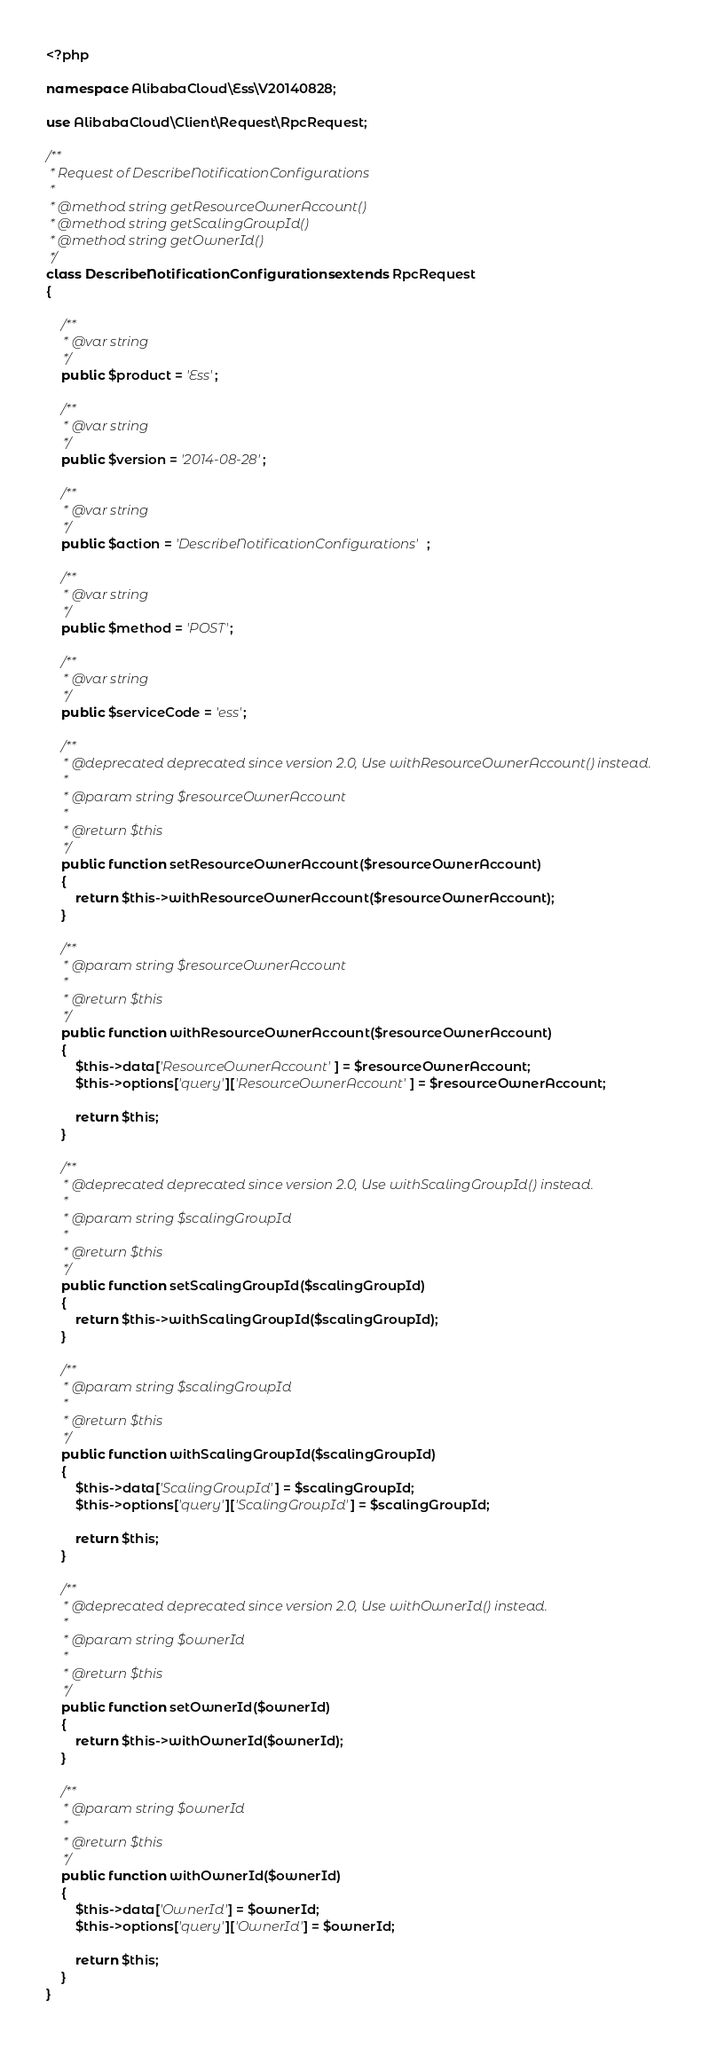<code> <loc_0><loc_0><loc_500><loc_500><_PHP_><?php

namespace AlibabaCloud\Ess\V20140828;

use AlibabaCloud\Client\Request\RpcRequest;

/**
 * Request of DescribeNotificationConfigurations
 *
 * @method string getResourceOwnerAccount()
 * @method string getScalingGroupId()
 * @method string getOwnerId()
 */
class DescribeNotificationConfigurations extends RpcRequest
{

    /**
     * @var string
     */
    public $product = 'Ess';

    /**
     * @var string
     */
    public $version = '2014-08-28';

    /**
     * @var string
     */
    public $action = 'DescribeNotificationConfigurations';

    /**
     * @var string
     */
    public $method = 'POST';

    /**
     * @var string
     */
    public $serviceCode = 'ess';

    /**
     * @deprecated deprecated since version 2.0, Use withResourceOwnerAccount() instead.
     *
     * @param string $resourceOwnerAccount
     *
     * @return $this
     */
    public function setResourceOwnerAccount($resourceOwnerAccount)
    {
        return $this->withResourceOwnerAccount($resourceOwnerAccount);
    }

    /**
     * @param string $resourceOwnerAccount
     *
     * @return $this
     */
    public function withResourceOwnerAccount($resourceOwnerAccount)
    {
        $this->data['ResourceOwnerAccount'] = $resourceOwnerAccount;
        $this->options['query']['ResourceOwnerAccount'] = $resourceOwnerAccount;

        return $this;
    }

    /**
     * @deprecated deprecated since version 2.0, Use withScalingGroupId() instead.
     *
     * @param string $scalingGroupId
     *
     * @return $this
     */
    public function setScalingGroupId($scalingGroupId)
    {
        return $this->withScalingGroupId($scalingGroupId);
    }

    /**
     * @param string $scalingGroupId
     *
     * @return $this
     */
    public function withScalingGroupId($scalingGroupId)
    {
        $this->data['ScalingGroupId'] = $scalingGroupId;
        $this->options['query']['ScalingGroupId'] = $scalingGroupId;

        return $this;
    }

    /**
     * @deprecated deprecated since version 2.0, Use withOwnerId() instead.
     *
     * @param string $ownerId
     *
     * @return $this
     */
    public function setOwnerId($ownerId)
    {
        return $this->withOwnerId($ownerId);
    }

    /**
     * @param string $ownerId
     *
     * @return $this
     */
    public function withOwnerId($ownerId)
    {
        $this->data['OwnerId'] = $ownerId;
        $this->options['query']['OwnerId'] = $ownerId;

        return $this;
    }
}
</code> 